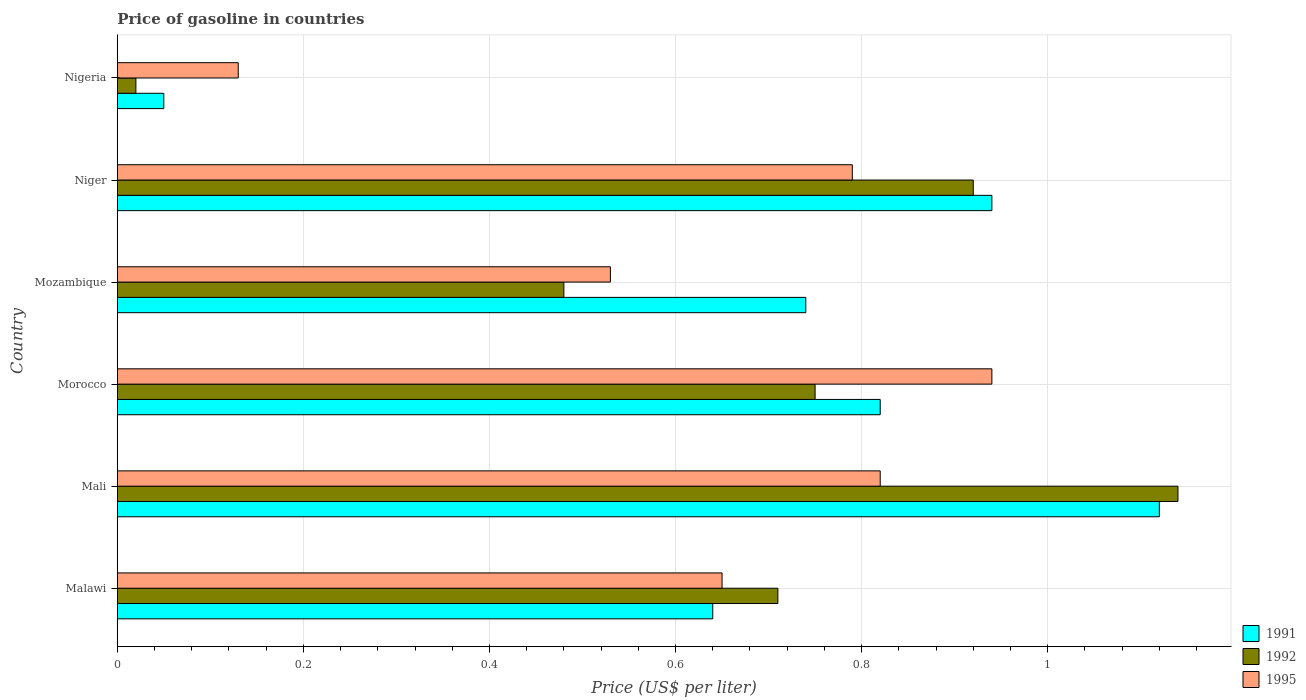How many bars are there on the 3rd tick from the top?
Keep it short and to the point. 3. How many bars are there on the 3rd tick from the bottom?
Provide a short and direct response. 3. What is the label of the 1st group of bars from the top?
Your response must be concise. Nigeria. What is the price of gasoline in 1991 in Nigeria?
Keep it short and to the point. 0.05. Across all countries, what is the minimum price of gasoline in 1995?
Provide a short and direct response. 0.13. In which country was the price of gasoline in 1991 maximum?
Offer a terse response. Mali. In which country was the price of gasoline in 1992 minimum?
Offer a terse response. Nigeria. What is the total price of gasoline in 1992 in the graph?
Your answer should be very brief. 4.02. What is the difference between the price of gasoline in 1992 in Mali and that in Niger?
Ensure brevity in your answer.  0.22. What is the difference between the price of gasoline in 1991 in Malawi and the price of gasoline in 1992 in Nigeria?
Your answer should be very brief. 0.62. What is the average price of gasoline in 1991 per country?
Your answer should be very brief. 0.72. What is the difference between the price of gasoline in 1995 and price of gasoline in 1992 in Morocco?
Offer a very short reply. 0.19. What is the ratio of the price of gasoline in 1991 in Malawi to that in Nigeria?
Ensure brevity in your answer.  12.8. What is the difference between the highest and the second highest price of gasoline in 1991?
Give a very brief answer. 0.18. What is the difference between the highest and the lowest price of gasoline in 1992?
Your response must be concise. 1.12. In how many countries, is the price of gasoline in 1991 greater than the average price of gasoline in 1991 taken over all countries?
Provide a succinct answer. 4. Is the sum of the price of gasoline in 1991 in Mali and Niger greater than the maximum price of gasoline in 1995 across all countries?
Provide a short and direct response. Yes. What does the 3rd bar from the bottom in Mozambique represents?
Provide a succinct answer. 1995. How many bars are there?
Your response must be concise. 18. How many countries are there in the graph?
Your answer should be compact. 6. What is the difference between two consecutive major ticks on the X-axis?
Ensure brevity in your answer.  0.2. Does the graph contain any zero values?
Keep it short and to the point. No. Does the graph contain grids?
Ensure brevity in your answer.  Yes. How many legend labels are there?
Provide a succinct answer. 3. What is the title of the graph?
Make the answer very short. Price of gasoline in countries. Does "1998" appear as one of the legend labels in the graph?
Keep it short and to the point. No. What is the label or title of the X-axis?
Provide a succinct answer. Price (US$ per liter). What is the Price (US$ per liter) in 1991 in Malawi?
Make the answer very short. 0.64. What is the Price (US$ per liter) of 1992 in Malawi?
Ensure brevity in your answer.  0.71. What is the Price (US$ per liter) in 1995 in Malawi?
Your answer should be compact. 0.65. What is the Price (US$ per liter) of 1991 in Mali?
Your response must be concise. 1.12. What is the Price (US$ per liter) in 1992 in Mali?
Offer a terse response. 1.14. What is the Price (US$ per liter) in 1995 in Mali?
Provide a short and direct response. 0.82. What is the Price (US$ per liter) of 1991 in Morocco?
Make the answer very short. 0.82. What is the Price (US$ per liter) of 1995 in Morocco?
Your response must be concise. 0.94. What is the Price (US$ per liter) in 1991 in Mozambique?
Give a very brief answer. 0.74. What is the Price (US$ per liter) in 1992 in Mozambique?
Offer a terse response. 0.48. What is the Price (US$ per liter) in 1995 in Mozambique?
Your answer should be very brief. 0.53. What is the Price (US$ per liter) in 1991 in Niger?
Your answer should be very brief. 0.94. What is the Price (US$ per liter) in 1992 in Niger?
Offer a terse response. 0.92. What is the Price (US$ per liter) in 1995 in Niger?
Your answer should be very brief. 0.79. What is the Price (US$ per liter) of 1995 in Nigeria?
Keep it short and to the point. 0.13. Across all countries, what is the maximum Price (US$ per liter) of 1991?
Offer a terse response. 1.12. Across all countries, what is the maximum Price (US$ per liter) in 1992?
Keep it short and to the point. 1.14. Across all countries, what is the maximum Price (US$ per liter) of 1995?
Offer a very short reply. 0.94. Across all countries, what is the minimum Price (US$ per liter) in 1992?
Keep it short and to the point. 0.02. Across all countries, what is the minimum Price (US$ per liter) of 1995?
Offer a very short reply. 0.13. What is the total Price (US$ per liter) in 1991 in the graph?
Your response must be concise. 4.31. What is the total Price (US$ per liter) in 1992 in the graph?
Offer a terse response. 4.02. What is the total Price (US$ per liter) in 1995 in the graph?
Make the answer very short. 3.86. What is the difference between the Price (US$ per liter) in 1991 in Malawi and that in Mali?
Provide a short and direct response. -0.48. What is the difference between the Price (US$ per liter) in 1992 in Malawi and that in Mali?
Your answer should be compact. -0.43. What is the difference between the Price (US$ per liter) in 1995 in Malawi and that in Mali?
Provide a succinct answer. -0.17. What is the difference between the Price (US$ per liter) of 1991 in Malawi and that in Morocco?
Make the answer very short. -0.18. What is the difference between the Price (US$ per liter) of 1992 in Malawi and that in Morocco?
Your response must be concise. -0.04. What is the difference between the Price (US$ per liter) in 1995 in Malawi and that in Morocco?
Ensure brevity in your answer.  -0.29. What is the difference between the Price (US$ per liter) of 1991 in Malawi and that in Mozambique?
Make the answer very short. -0.1. What is the difference between the Price (US$ per liter) in 1992 in Malawi and that in Mozambique?
Offer a very short reply. 0.23. What is the difference between the Price (US$ per liter) in 1995 in Malawi and that in Mozambique?
Your answer should be very brief. 0.12. What is the difference between the Price (US$ per liter) of 1992 in Malawi and that in Niger?
Keep it short and to the point. -0.21. What is the difference between the Price (US$ per liter) in 1995 in Malawi and that in Niger?
Provide a short and direct response. -0.14. What is the difference between the Price (US$ per liter) of 1991 in Malawi and that in Nigeria?
Your answer should be compact. 0.59. What is the difference between the Price (US$ per liter) in 1992 in Malawi and that in Nigeria?
Provide a succinct answer. 0.69. What is the difference between the Price (US$ per liter) of 1995 in Malawi and that in Nigeria?
Keep it short and to the point. 0.52. What is the difference between the Price (US$ per liter) of 1991 in Mali and that in Morocco?
Your answer should be very brief. 0.3. What is the difference between the Price (US$ per liter) in 1992 in Mali and that in Morocco?
Make the answer very short. 0.39. What is the difference between the Price (US$ per liter) of 1995 in Mali and that in Morocco?
Your answer should be compact. -0.12. What is the difference between the Price (US$ per liter) in 1991 in Mali and that in Mozambique?
Your response must be concise. 0.38. What is the difference between the Price (US$ per liter) in 1992 in Mali and that in Mozambique?
Your response must be concise. 0.66. What is the difference between the Price (US$ per liter) of 1995 in Mali and that in Mozambique?
Offer a terse response. 0.29. What is the difference between the Price (US$ per liter) of 1991 in Mali and that in Niger?
Provide a succinct answer. 0.18. What is the difference between the Price (US$ per liter) in 1992 in Mali and that in Niger?
Provide a succinct answer. 0.22. What is the difference between the Price (US$ per liter) in 1991 in Mali and that in Nigeria?
Your answer should be compact. 1.07. What is the difference between the Price (US$ per liter) in 1992 in Mali and that in Nigeria?
Offer a very short reply. 1.12. What is the difference between the Price (US$ per liter) in 1995 in Mali and that in Nigeria?
Offer a terse response. 0.69. What is the difference between the Price (US$ per liter) in 1991 in Morocco and that in Mozambique?
Offer a very short reply. 0.08. What is the difference between the Price (US$ per liter) of 1992 in Morocco and that in Mozambique?
Your response must be concise. 0.27. What is the difference between the Price (US$ per liter) of 1995 in Morocco and that in Mozambique?
Give a very brief answer. 0.41. What is the difference between the Price (US$ per liter) in 1991 in Morocco and that in Niger?
Offer a terse response. -0.12. What is the difference between the Price (US$ per liter) of 1992 in Morocco and that in Niger?
Offer a very short reply. -0.17. What is the difference between the Price (US$ per liter) in 1991 in Morocco and that in Nigeria?
Keep it short and to the point. 0.77. What is the difference between the Price (US$ per liter) in 1992 in Morocco and that in Nigeria?
Provide a short and direct response. 0.73. What is the difference between the Price (US$ per liter) in 1995 in Morocco and that in Nigeria?
Your response must be concise. 0.81. What is the difference between the Price (US$ per liter) of 1991 in Mozambique and that in Niger?
Keep it short and to the point. -0.2. What is the difference between the Price (US$ per liter) in 1992 in Mozambique and that in Niger?
Your response must be concise. -0.44. What is the difference between the Price (US$ per liter) of 1995 in Mozambique and that in Niger?
Provide a succinct answer. -0.26. What is the difference between the Price (US$ per liter) of 1991 in Mozambique and that in Nigeria?
Make the answer very short. 0.69. What is the difference between the Price (US$ per liter) in 1992 in Mozambique and that in Nigeria?
Make the answer very short. 0.46. What is the difference between the Price (US$ per liter) of 1995 in Mozambique and that in Nigeria?
Ensure brevity in your answer.  0.4. What is the difference between the Price (US$ per liter) of 1991 in Niger and that in Nigeria?
Ensure brevity in your answer.  0.89. What is the difference between the Price (US$ per liter) in 1992 in Niger and that in Nigeria?
Offer a terse response. 0.9. What is the difference between the Price (US$ per liter) of 1995 in Niger and that in Nigeria?
Keep it short and to the point. 0.66. What is the difference between the Price (US$ per liter) of 1991 in Malawi and the Price (US$ per liter) of 1995 in Mali?
Make the answer very short. -0.18. What is the difference between the Price (US$ per liter) of 1992 in Malawi and the Price (US$ per liter) of 1995 in Mali?
Give a very brief answer. -0.11. What is the difference between the Price (US$ per liter) of 1991 in Malawi and the Price (US$ per liter) of 1992 in Morocco?
Give a very brief answer. -0.11. What is the difference between the Price (US$ per liter) of 1991 in Malawi and the Price (US$ per liter) of 1995 in Morocco?
Ensure brevity in your answer.  -0.3. What is the difference between the Price (US$ per liter) in 1992 in Malawi and the Price (US$ per liter) in 1995 in Morocco?
Give a very brief answer. -0.23. What is the difference between the Price (US$ per liter) in 1991 in Malawi and the Price (US$ per liter) in 1992 in Mozambique?
Give a very brief answer. 0.16. What is the difference between the Price (US$ per liter) of 1991 in Malawi and the Price (US$ per liter) of 1995 in Mozambique?
Offer a very short reply. 0.11. What is the difference between the Price (US$ per liter) in 1992 in Malawi and the Price (US$ per liter) in 1995 in Mozambique?
Provide a succinct answer. 0.18. What is the difference between the Price (US$ per liter) in 1991 in Malawi and the Price (US$ per liter) in 1992 in Niger?
Your answer should be compact. -0.28. What is the difference between the Price (US$ per liter) in 1991 in Malawi and the Price (US$ per liter) in 1995 in Niger?
Keep it short and to the point. -0.15. What is the difference between the Price (US$ per liter) of 1992 in Malawi and the Price (US$ per liter) of 1995 in Niger?
Keep it short and to the point. -0.08. What is the difference between the Price (US$ per liter) of 1991 in Malawi and the Price (US$ per liter) of 1992 in Nigeria?
Your answer should be very brief. 0.62. What is the difference between the Price (US$ per liter) of 1991 in Malawi and the Price (US$ per liter) of 1995 in Nigeria?
Offer a very short reply. 0.51. What is the difference between the Price (US$ per liter) in 1992 in Malawi and the Price (US$ per liter) in 1995 in Nigeria?
Your answer should be very brief. 0.58. What is the difference between the Price (US$ per liter) of 1991 in Mali and the Price (US$ per liter) of 1992 in Morocco?
Provide a short and direct response. 0.37. What is the difference between the Price (US$ per liter) in 1991 in Mali and the Price (US$ per liter) in 1995 in Morocco?
Provide a short and direct response. 0.18. What is the difference between the Price (US$ per liter) in 1991 in Mali and the Price (US$ per liter) in 1992 in Mozambique?
Offer a very short reply. 0.64. What is the difference between the Price (US$ per liter) of 1991 in Mali and the Price (US$ per liter) of 1995 in Mozambique?
Your response must be concise. 0.59. What is the difference between the Price (US$ per liter) in 1992 in Mali and the Price (US$ per liter) in 1995 in Mozambique?
Give a very brief answer. 0.61. What is the difference between the Price (US$ per liter) of 1991 in Mali and the Price (US$ per liter) of 1992 in Niger?
Offer a very short reply. 0.2. What is the difference between the Price (US$ per liter) of 1991 in Mali and the Price (US$ per liter) of 1995 in Niger?
Give a very brief answer. 0.33. What is the difference between the Price (US$ per liter) of 1991 in Mali and the Price (US$ per liter) of 1992 in Nigeria?
Keep it short and to the point. 1.1. What is the difference between the Price (US$ per liter) in 1991 in Morocco and the Price (US$ per liter) in 1992 in Mozambique?
Your response must be concise. 0.34. What is the difference between the Price (US$ per liter) of 1991 in Morocco and the Price (US$ per liter) of 1995 in Mozambique?
Give a very brief answer. 0.29. What is the difference between the Price (US$ per liter) in 1992 in Morocco and the Price (US$ per liter) in 1995 in Mozambique?
Give a very brief answer. 0.22. What is the difference between the Price (US$ per liter) of 1991 in Morocco and the Price (US$ per liter) of 1995 in Niger?
Provide a succinct answer. 0.03. What is the difference between the Price (US$ per liter) in 1992 in Morocco and the Price (US$ per liter) in 1995 in Niger?
Your answer should be very brief. -0.04. What is the difference between the Price (US$ per liter) in 1991 in Morocco and the Price (US$ per liter) in 1995 in Nigeria?
Your answer should be very brief. 0.69. What is the difference between the Price (US$ per liter) of 1992 in Morocco and the Price (US$ per liter) of 1995 in Nigeria?
Make the answer very short. 0.62. What is the difference between the Price (US$ per liter) in 1991 in Mozambique and the Price (US$ per liter) in 1992 in Niger?
Offer a very short reply. -0.18. What is the difference between the Price (US$ per liter) of 1992 in Mozambique and the Price (US$ per liter) of 1995 in Niger?
Your response must be concise. -0.31. What is the difference between the Price (US$ per liter) of 1991 in Mozambique and the Price (US$ per liter) of 1992 in Nigeria?
Keep it short and to the point. 0.72. What is the difference between the Price (US$ per liter) in 1991 in Mozambique and the Price (US$ per liter) in 1995 in Nigeria?
Offer a terse response. 0.61. What is the difference between the Price (US$ per liter) of 1991 in Niger and the Price (US$ per liter) of 1992 in Nigeria?
Your answer should be very brief. 0.92. What is the difference between the Price (US$ per liter) in 1991 in Niger and the Price (US$ per liter) in 1995 in Nigeria?
Keep it short and to the point. 0.81. What is the difference between the Price (US$ per liter) of 1992 in Niger and the Price (US$ per liter) of 1995 in Nigeria?
Make the answer very short. 0.79. What is the average Price (US$ per liter) in 1991 per country?
Give a very brief answer. 0.72. What is the average Price (US$ per liter) in 1992 per country?
Your answer should be very brief. 0.67. What is the average Price (US$ per liter) of 1995 per country?
Offer a very short reply. 0.64. What is the difference between the Price (US$ per liter) in 1991 and Price (US$ per liter) in 1992 in Malawi?
Your response must be concise. -0.07. What is the difference between the Price (US$ per liter) of 1991 and Price (US$ per liter) of 1995 in Malawi?
Your response must be concise. -0.01. What is the difference between the Price (US$ per liter) of 1992 and Price (US$ per liter) of 1995 in Malawi?
Offer a terse response. 0.06. What is the difference between the Price (US$ per liter) in 1991 and Price (US$ per liter) in 1992 in Mali?
Keep it short and to the point. -0.02. What is the difference between the Price (US$ per liter) in 1991 and Price (US$ per liter) in 1995 in Mali?
Your answer should be compact. 0.3. What is the difference between the Price (US$ per liter) of 1992 and Price (US$ per liter) of 1995 in Mali?
Your answer should be very brief. 0.32. What is the difference between the Price (US$ per liter) of 1991 and Price (US$ per liter) of 1992 in Morocco?
Your answer should be compact. 0.07. What is the difference between the Price (US$ per liter) of 1991 and Price (US$ per liter) of 1995 in Morocco?
Keep it short and to the point. -0.12. What is the difference between the Price (US$ per liter) in 1992 and Price (US$ per liter) in 1995 in Morocco?
Make the answer very short. -0.19. What is the difference between the Price (US$ per liter) in 1991 and Price (US$ per liter) in 1992 in Mozambique?
Ensure brevity in your answer.  0.26. What is the difference between the Price (US$ per liter) of 1991 and Price (US$ per liter) of 1995 in Mozambique?
Provide a succinct answer. 0.21. What is the difference between the Price (US$ per liter) in 1992 and Price (US$ per liter) in 1995 in Mozambique?
Keep it short and to the point. -0.05. What is the difference between the Price (US$ per liter) in 1991 and Price (US$ per liter) in 1995 in Niger?
Your response must be concise. 0.15. What is the difference between the Price (US$ per liter) in 1992 and Price (US$ per liter) in 1995 in Niger?
Provide a short and direct response. 0.13. What is the difference between the Price (US$ per liter) in 1991 and Price (US$ per liter) in 1992 in Nigeria?
Keep it short and to the point. 0.03. What is the difference between the Price (US$ per liter) of 1991 and Price (US$ per liter) of 1995 in Nigeria?
Offer a very short reply. -0.08. What is the difference between the Price (US$ per liter) in 1992 and Price (US$ per liter) in 1995 in Nigeria?
Give a very brief answer. -0.11. What is the ratio of the Price (US$ per liter) in 1992 in Malawi to that in Mali?
Your response must be concise. 0.62. What is the ratio of the Price (US$ per liter) of 1995 in Malawi to that in Mali?
Ensure brevity in your answer.  0.79. What is the ratio of the Price (US$ per liter) in 1991 in Malawi to that in Morocco?
Your answer should be compact. 0.78. What is the ratio of the Price (US$ per liter) in 1992 in Malawi to that in Morocco?
Your answer should be very brief. 0.95. What is the ratio of the Price (US$ per liter) of 1995 in Malawi to that in Morocco?
Make the answer very short. 0.69. What is the ratio of the Price (US$ per liter) in 1991 in Malawi to that in Mozambique?
Your response must be concise. 0.86. What is the ratio of the Price (US$ per liter) in 1992 in Malawi to that in Mozambique?
Your answer should be very brief. 1.48. What is the ratio of the Price (US$ per liter) in 1995 in Malawi to that in Mozambique?
Provide a short and direct response. 1.23. What is the ratio of the Price (US$ per liter) in 1991 in Malawi to that in Niger?
Your response must be concise. 0.68. What is the ratio of the Price (US$ per liter) of 1992 in Malawi to that in Niger?
Your response must be concise. 0.77. What is the ratio of the Price (US$ per liter) in 1995 in Malawi to that in Niger?
Offer a very short reply. 0.82. What is the ratio of the Price (US$ per liter) in 1991 in Malawi to that in Nigeria?
Make the answer very short. 12.8. What is the ratio of the Price (US$ per liter) of 1992 in Malawi to that in Nigeria?
Offer a very short reply. 35.5. What is the ratio of the Price (US$ per liter) in 1991 in Mali to that in Morocco?
Keep it short and to the point. 1.37. What is the ratio of the Price (US$ per liter) of 1992 in Mali to that in Morocco?
Ensure brevity in your answer.  1.52. What is the ratio of the Price (US$ per liter) in 1995 in Mali to that in Morocco?
Offer a very short reply. 0.87. What is the ratio of the Price (US$ per liter) in 1991 in Mali to that in Mozambique?
Offer a terse response. 1.51. What is the ratio of the Price (US$ per liter) in 1992 in Mali to that in Mozambique?
Provide a succinct answer. 2.38. What is the ratio of the Price (US$ per liter) of 1995 in Mali to that in Mozambique?
Your response must be concise. 1.55. What is the ratio of the Price (US$ per liter) of 1991 in Mali to that in Niger?
Your answer should be compact. 1.19. What is the ratio of the Price (US$ per liter) in 1992 in Mali to that in Niger?
Your answer should be very brief. 1.24. What is the ratio of the Price (US$ per liter) in 1995 in Mali to that in Niger?
Offer a very short reply. 1.04. What is the ratio of the Price (US$ per liter) in 1991 in Mali to that in Nigeria?
Your answer should be very brief. 22.4. What is the ratio of the Price (US$ per liter) of 1995 in Mali to that in Nigeria?
Make the answer very short. 6.31. What is the ratio of the Price (US$ per liter) in 1991 in Morocco to that in Mozambique?
Give a very brief answer. 1.11. What is the ratio of the Price (US$ per liter) in 1992 in Morocco to that in Mozambique?
Provide a succinct answer. 1.56. What is the ratio of the Price (US$ per liter) in 1995 in Morocco to that in Mozambique?
Make the answer very short. 1.77. What is the ratio of the Price (US$ per liter) in 1991 in Morocco to that in Niger?
Ensure brevity in your answer.  0.87. What is the ratio of the Price (US$ per liter) of 1992 in Morocco to that in Niger?
Provide a succinct answer. 0.82. What is the ratio of the Price (US$ per liter) of 1995 in Morocco to that in Niger?
Ensure brevity in your answer.  1.19. What is the ratio of the Price (US$ per liter) in 1992 in Morocco to that in Nigeria?
Make the answer very short. 37.5. What is the ratio of the Price (US$ per liter) in 1995 in Morocco to that in Nigeria?
Offer a terse response. 7.23. What is the ratio of the Price (US$ per liter) of 1991 in Mozambique to that in Niger?
Provide a succinct answer. 0.79. What is the ratio of the Price (US$ per liter) of 1992 in Mozambique to that in Niger?
Your response must be concise. 0.52. What is the ratio of the Price (US$ per liter) in 1995 in Mozambique to that in Niger?
Offer a very short reply. 0.67. What is the ratio of the Price (US$ per liter) of 1995 in Mozambique to that in Nigeria?
Offer a very short reply. 4.08. What is the ratio of the Price (US$ per liter) in 1991 in Niger to that in Nigeria?
Provide a succinct answer. 18.8. What is the ratio of the Price (US$ per liter) of 1995 in Niger to that in Nigeria?
Ensure brevity in your answer.  6.08. What is the difference between the highest and the second highest Price (US$ per liter) in 1991?
Provide a short and direct response. 0.18. What is the difference between the highest and the second highest Price (US$ per liter) in 1992?
Give a very brief answer. 0.22. What is the difference between the highest and the second highest Price (US$ per liter) in 1995?
Keep it short and to the point. 0.12. What is the difference between the highest and the lowest Price (US$ per liter) in 1991?
Your response must be concise. 1.07. What is the difference between the highest and the lowest Price (US$ per liter) in 1992?
Your answer should be compact. 1.12. What is the difference between the highest and the lowest Price (US$ per liter) of 1995?
Your answer should be compact. 0.81. 